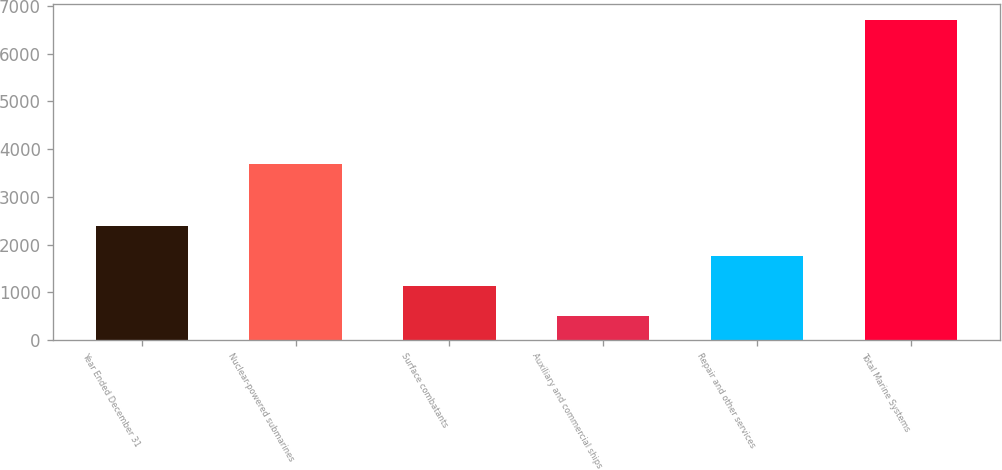<chart> <loc_0><loc_0><loc_500><loc_500><bar_chart><fcel>Year Ended December 31<fcel>Nuclear-powered submarines<fcel>Surface combatants<fcel>Auxiliary and commercial ships<fcel>Repair and other services<fcel>Total Marine Systems<nl><fcel>2381.6<fcel>3697<fcel>1139<fcel>499<fcel>1760.3<fcel>6712<nl></chart> 